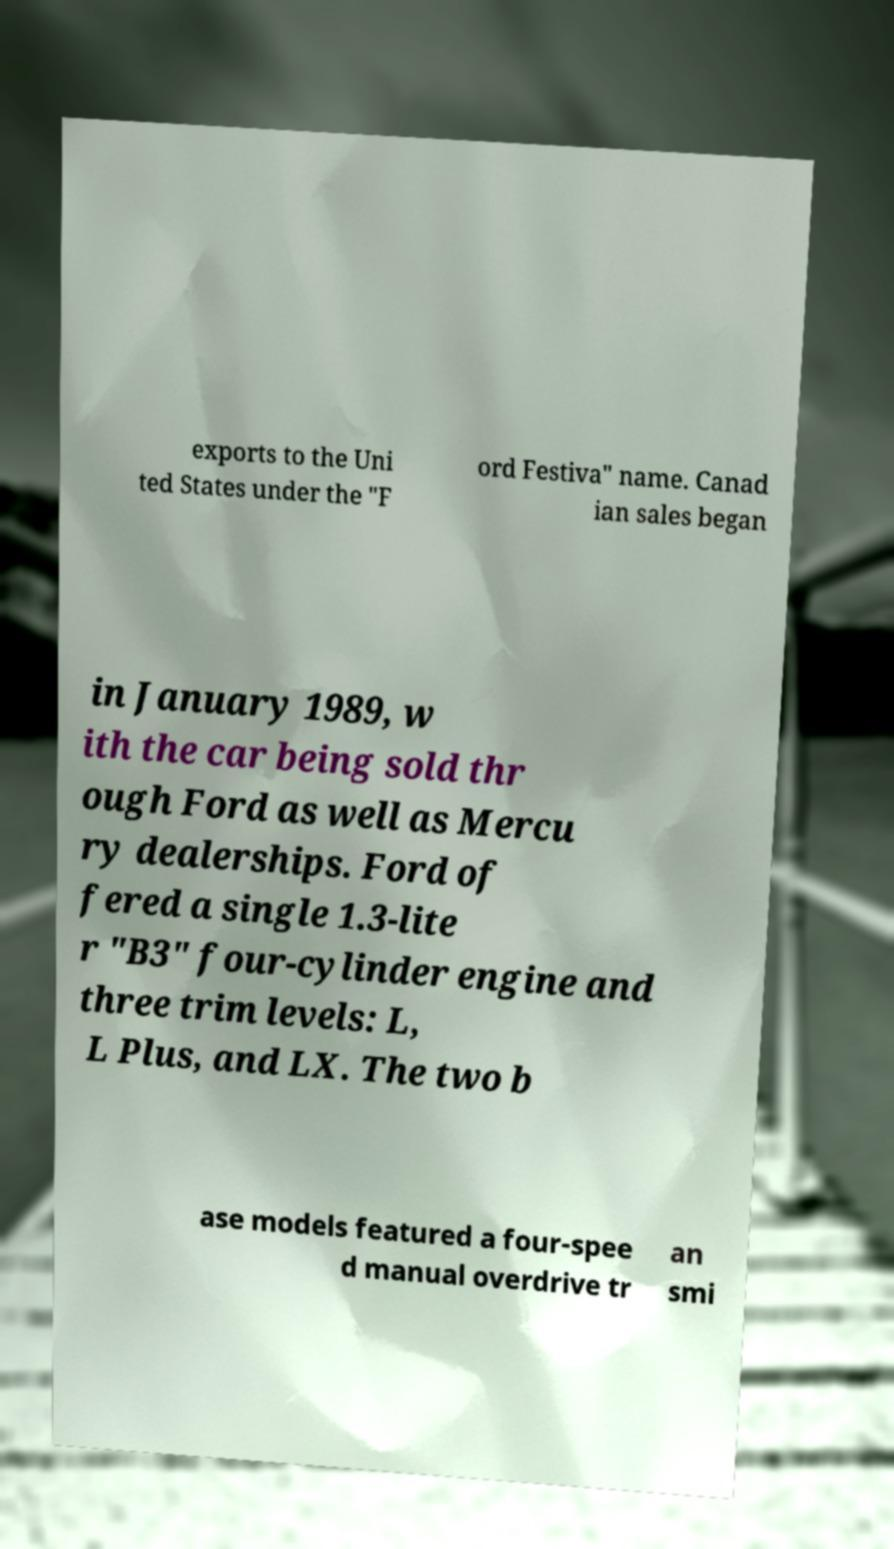Please read and relay the text visible in this image. What does it say? exports to the Uni ted States under the "F ord Festiva" name. Canad ian sales began in January 1989, w ith the car being sold thr ough Ford as well as Mercu ry dealerships. Ford of fered a single 1.3-lite r "B3" four-cylinder engine and three trim levels: L, L Plus, and LX. The two b ase models featured a four-spee d manual overdrive tr an smi 